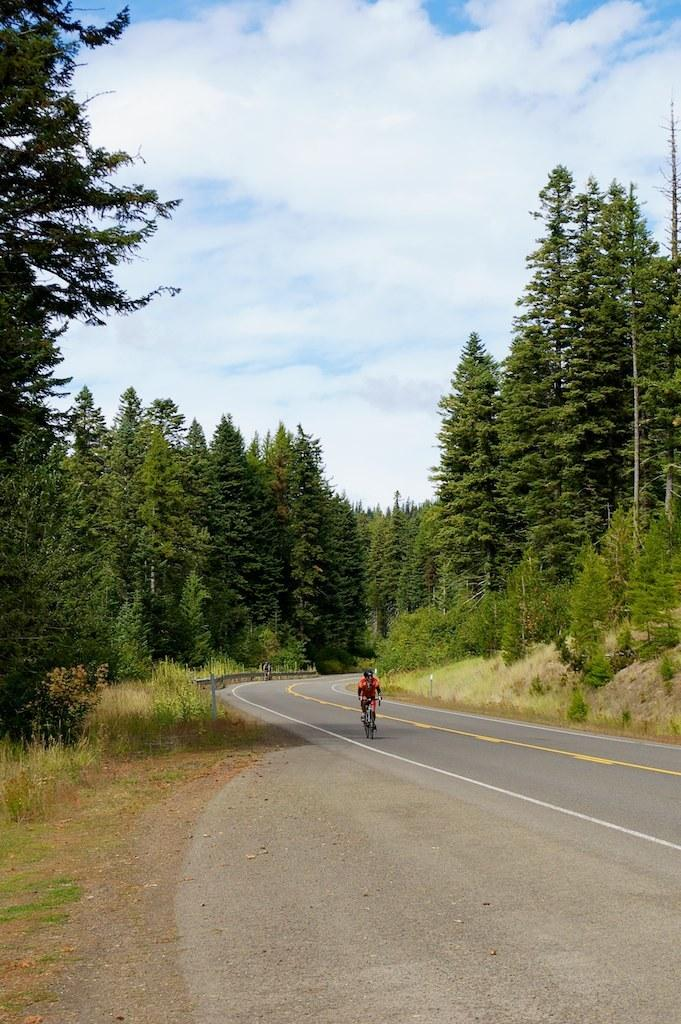What is the person in the image doing? The person is riding a bicycle in the image. Where is the person riding the bicycle? The person is on the road. What type of vegetation can be seen in the image? There is grass, plants, and trees visible in the image. What is visible in the background of the image? The sky is visible in the background of the image, and there are clouds in the sky. What type of sign can be seen on the bicycle in the image? There is no sign visible on the bicycle in the image. How does the person riding the bicycle cover the distance between the trees in the image? The person riding the bicycle covers the distance by pedaling the bicycle, not by covering it. 